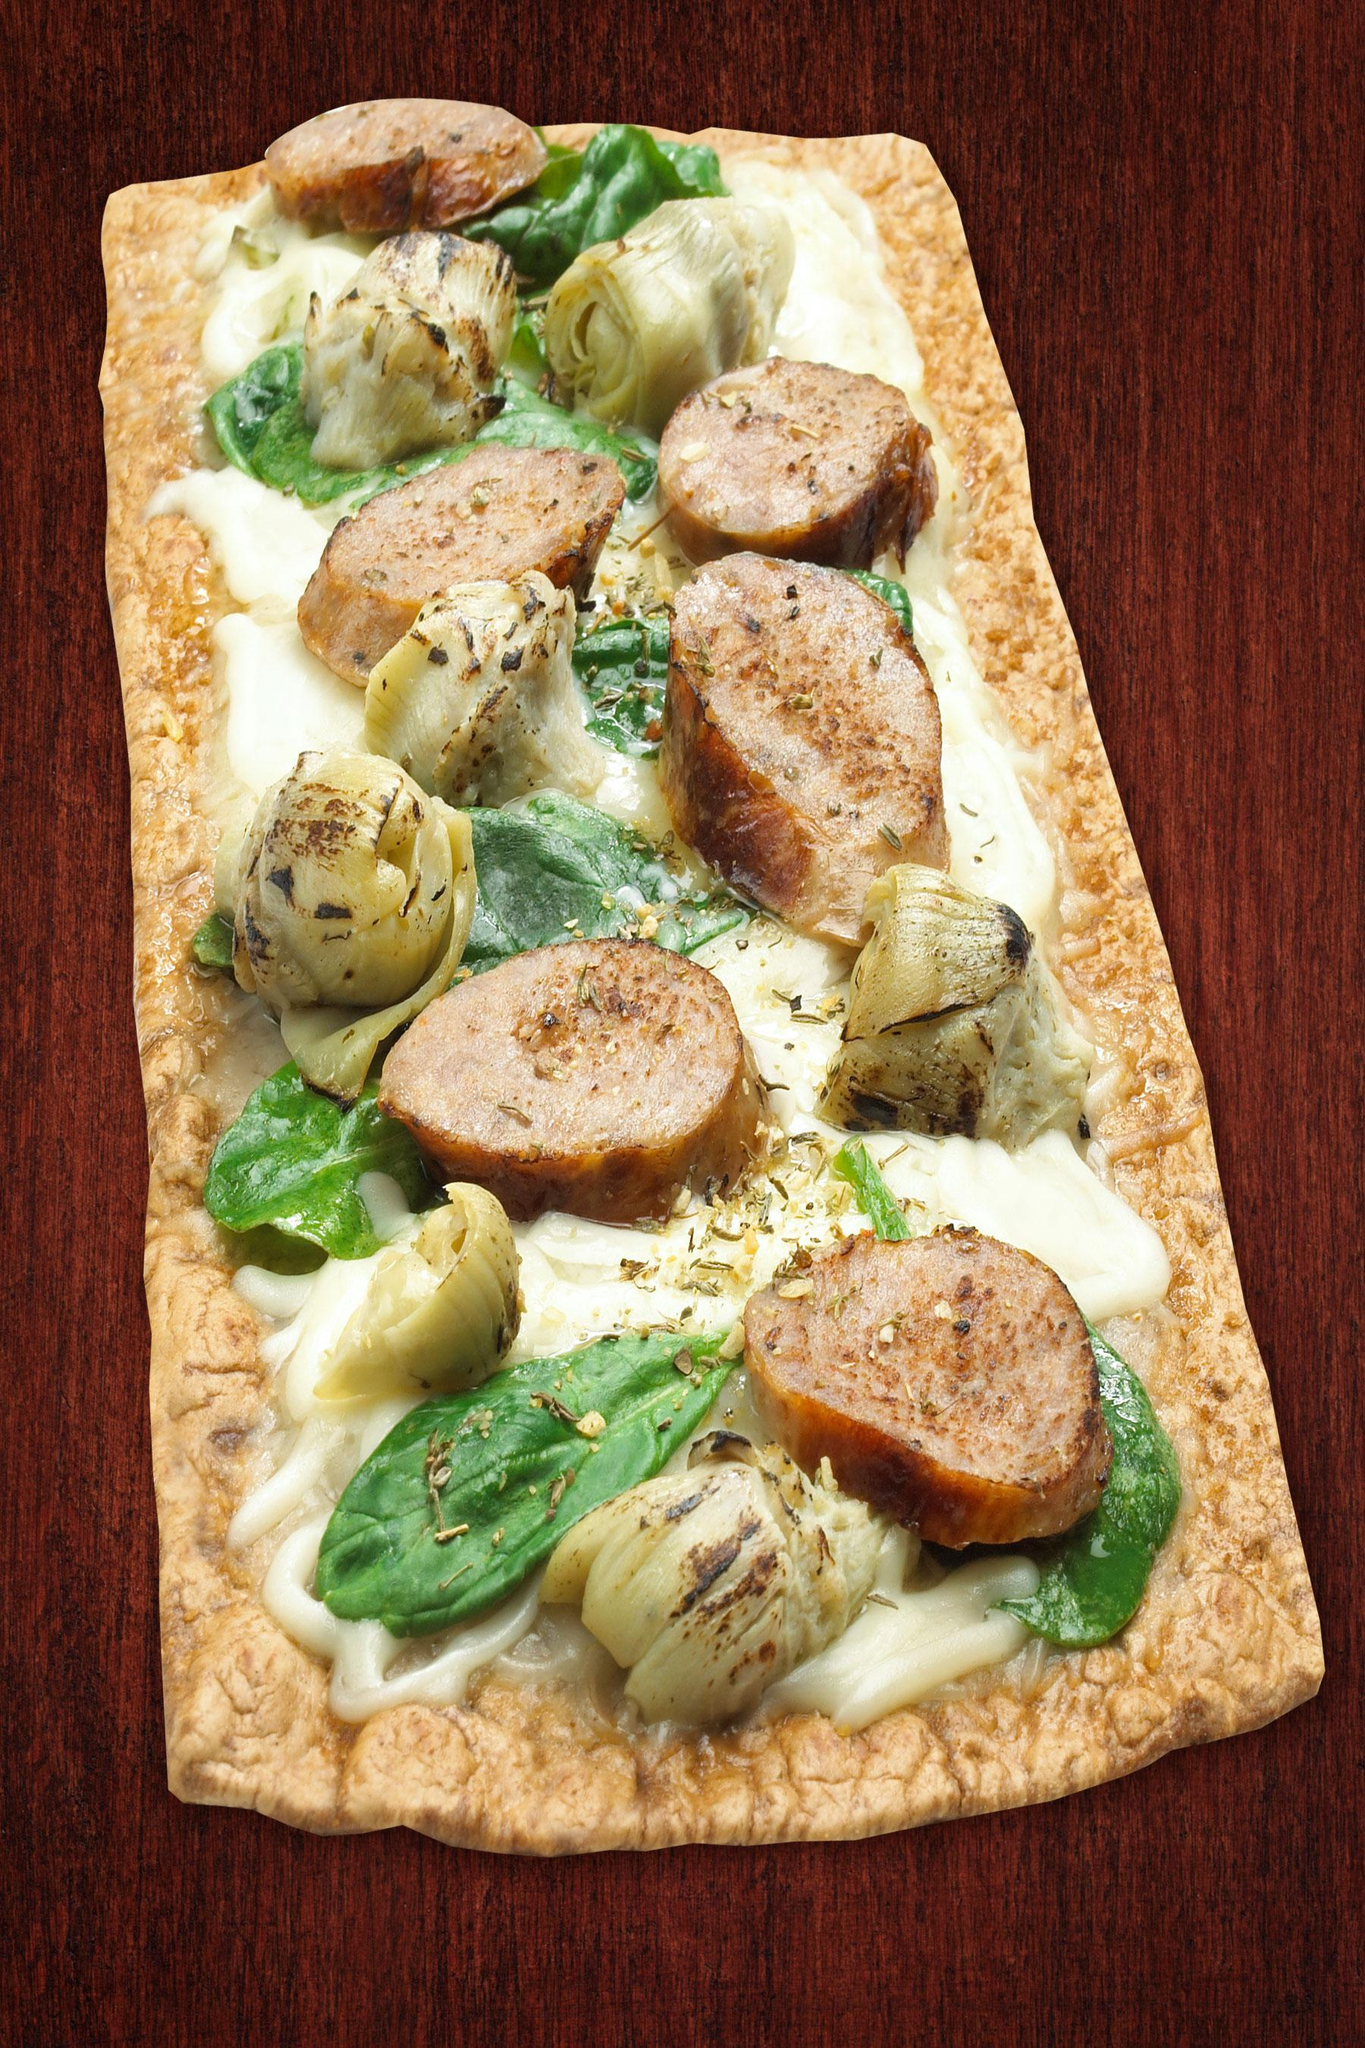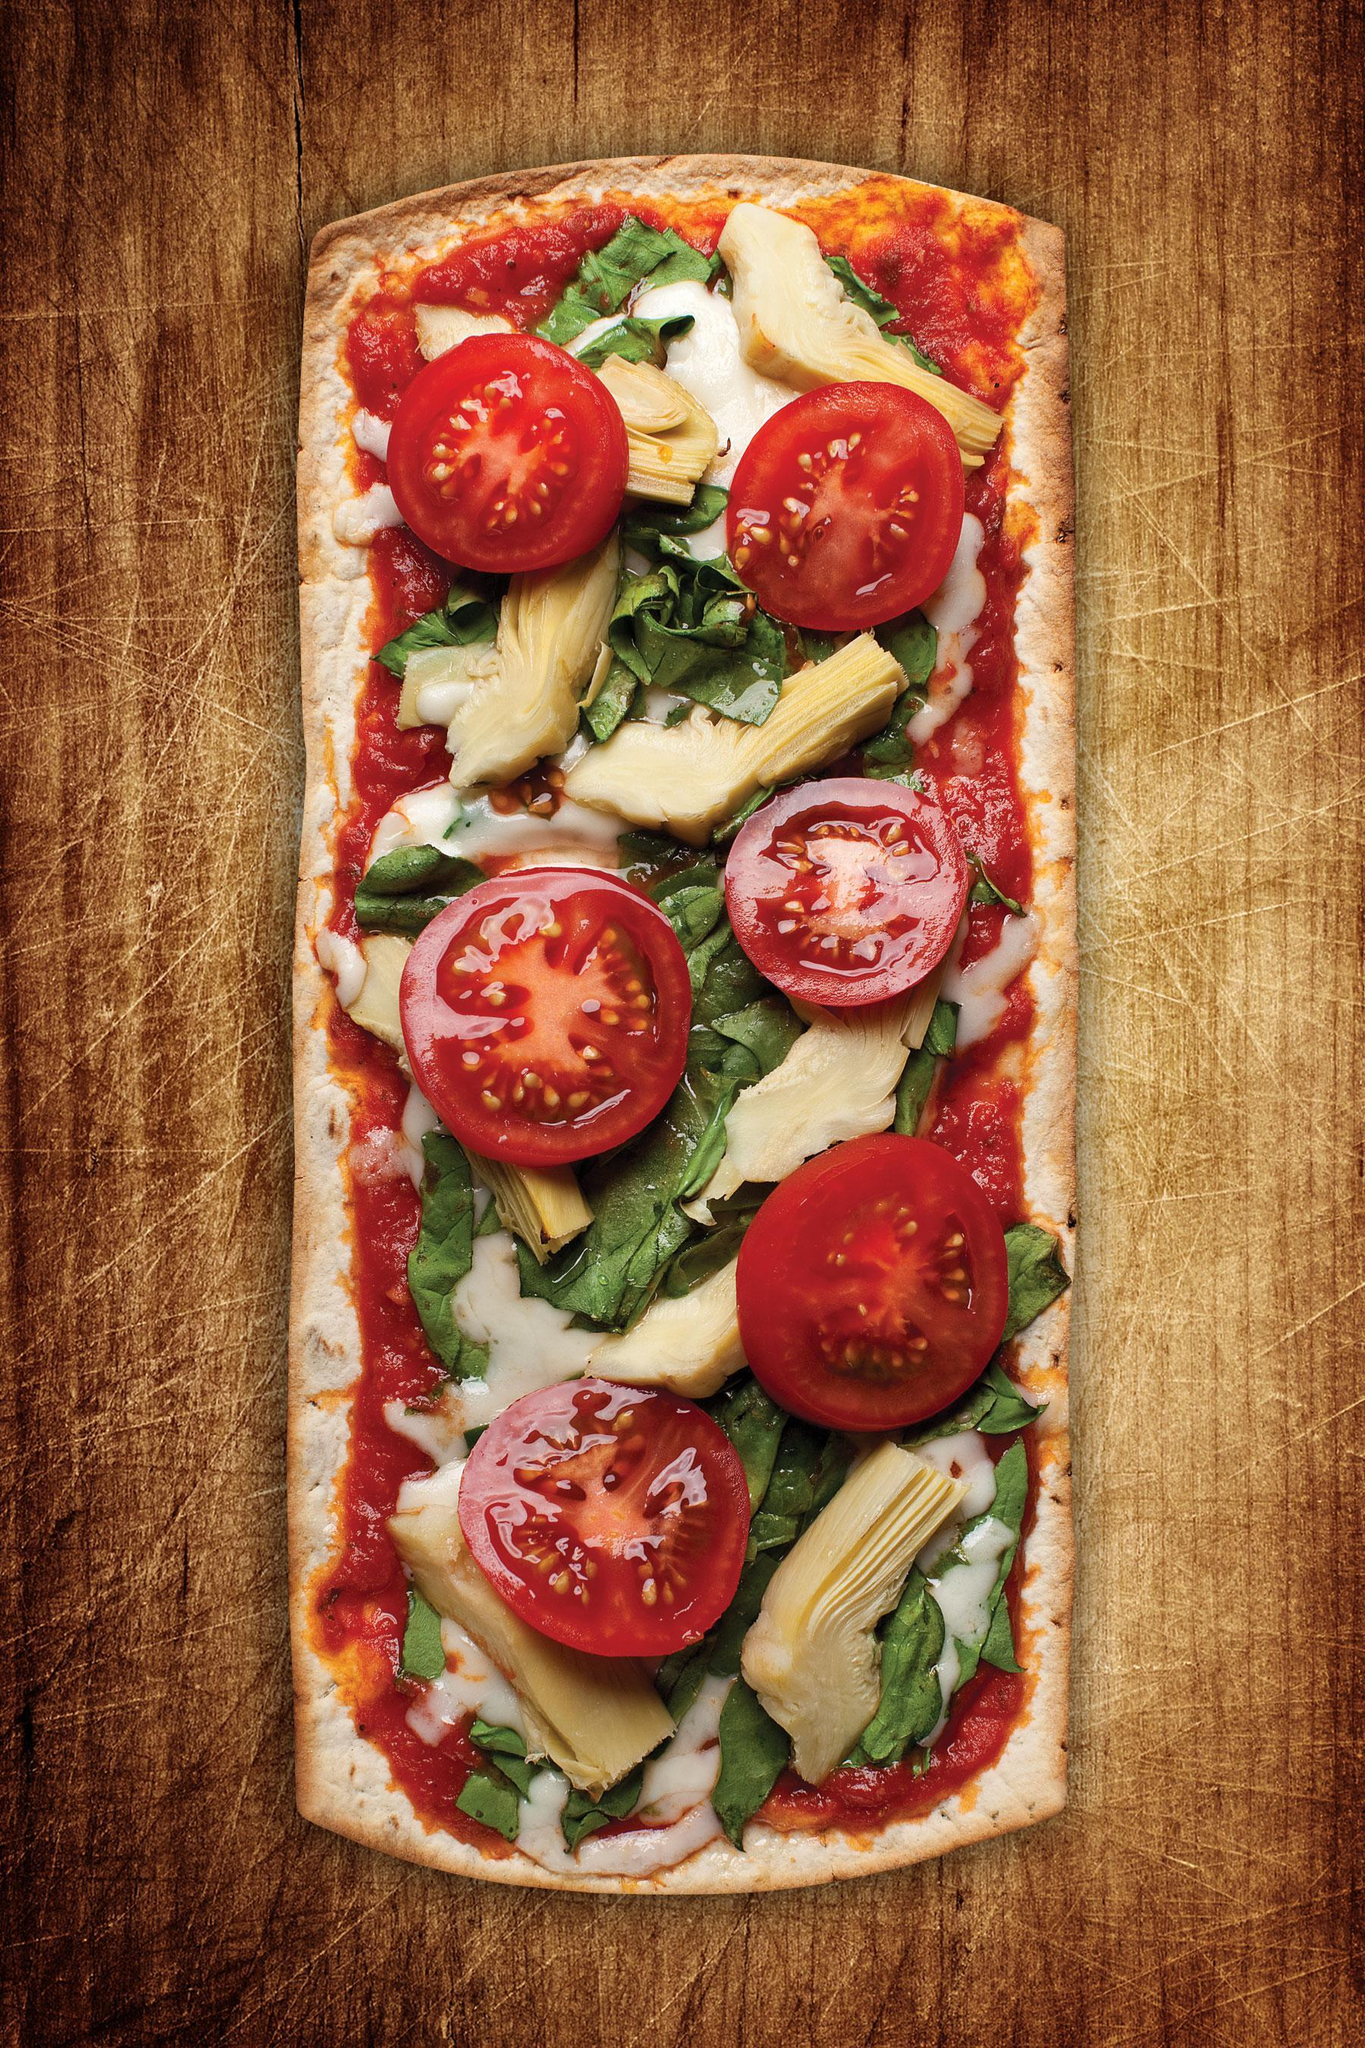The first image is the image on the left, the second image is the image on the right. For the images displayed, is the sentence "One image shows a round pizza with none of its slices missing, sitting in an open cardboard box positioned with the lid at the top." factually correct? Answer yes or no. No. The first image is the image on the left, the second image is the image on the right. Analyze the images presented: Is the assertion "There is at least one rectangular shaped pizza." valid? Answer yes or no. Yes. 